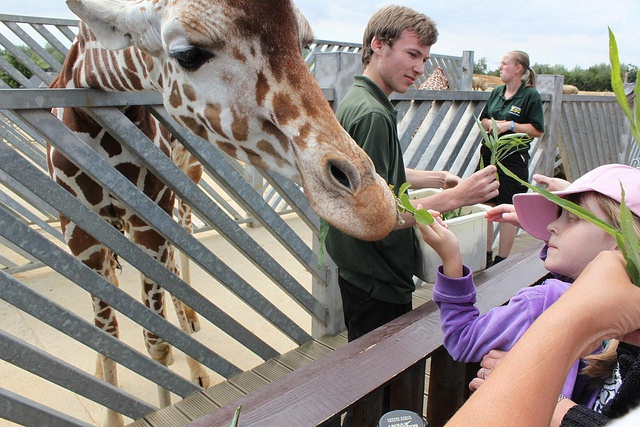Describe the objects in this image and their specific colors. I can see giraffe in white, gray, darkgray, and black tones, people in white, black, darkgray, and gray tones, people in white, darkgray, lavender, brown, and pink tones, people in white, tan, and salmon tones, and people in white, black, gray, and darkgray tones in this image. 